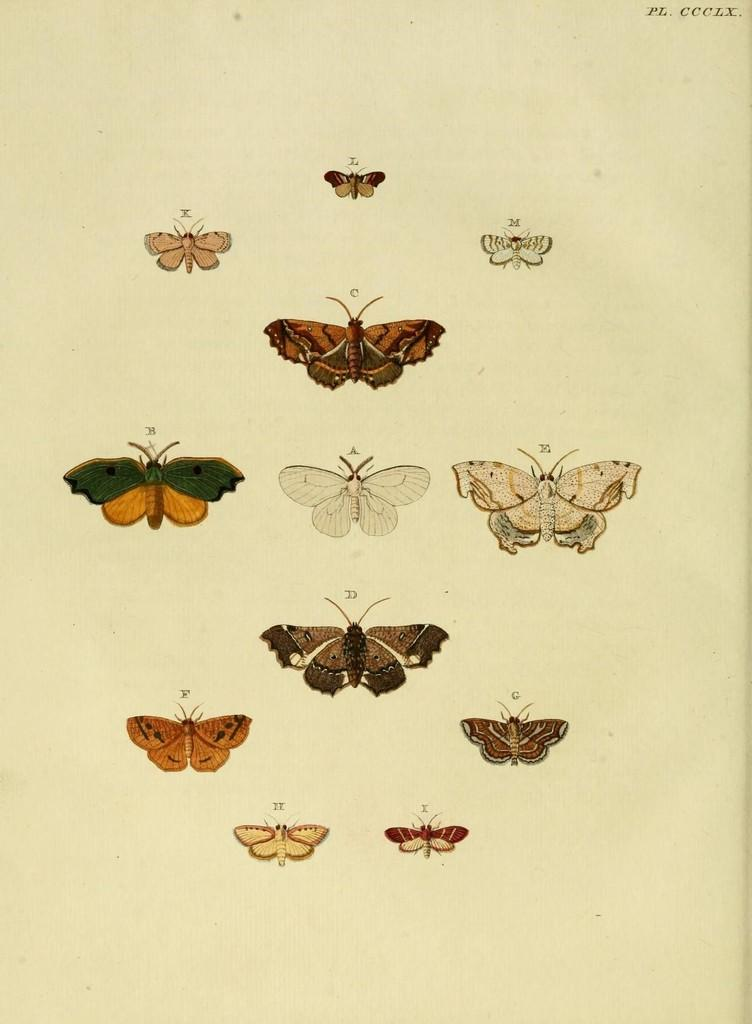What is depicted on the page in the image? There are butterflies on a page in the image. What else can be seen in the image besides the butterflies? There is text visible in the top right corner of the image. How many circles are present in the image? There is no circle present in the image. What type of legal advice can be found in the image? There is no lawyer or legal advice present in the image; it features butterflies on a page and text in the top right corner. 